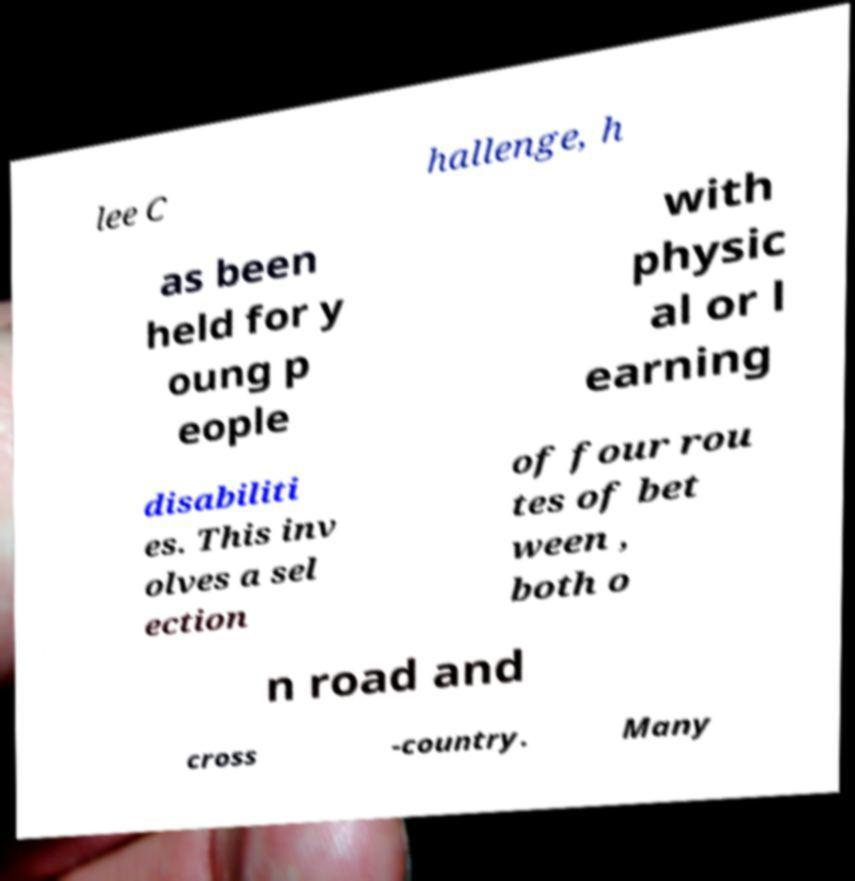For documentation purposes, I need the text within this image transcribed. Could you provide that? lee C hallenge, h as been held for y oung p eople with physic al or l earning disabiliti es. This inv olves a sel ection of four rou tes of bet ween , both o n road and cross -country. Many 